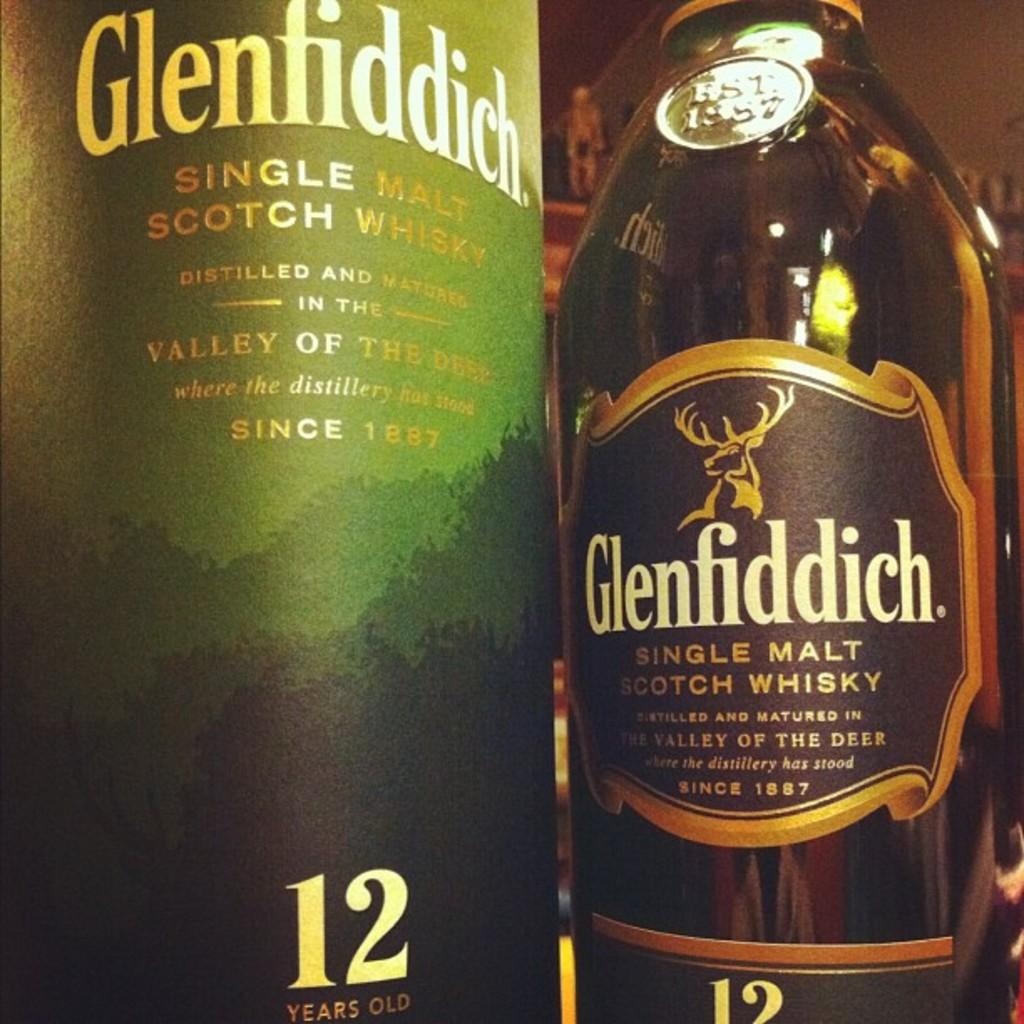<image>
Present a compact description of the photo's key features. A bottle of Glenfiddich features a stag on the label. 